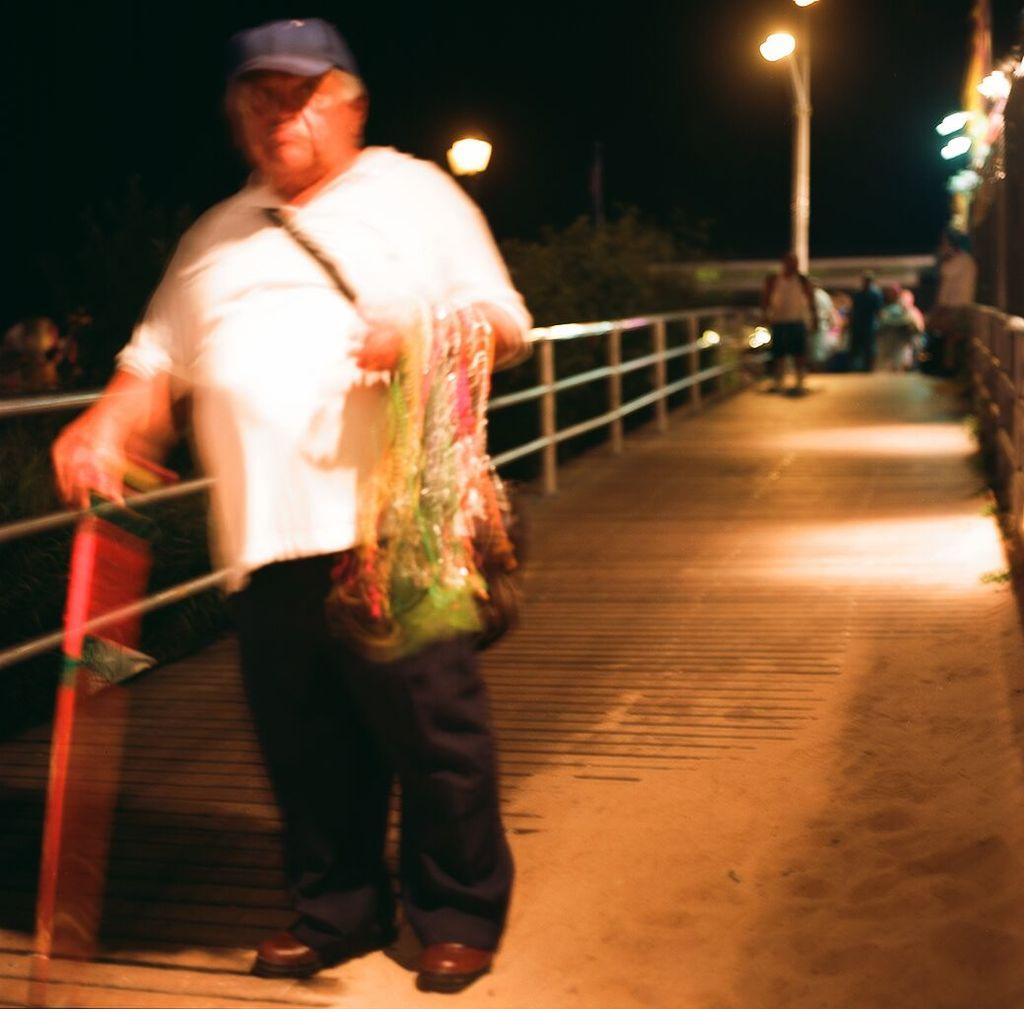What is the position of the man in the image? The man is on the left side of the image. Are there any other people in the image besides the man? Yes, there are other people on the right side of the image. What can be seen at the top side of the image? There is a pole at the top side of the image. How many books can be seen in the man's eye in the image? There are no books visible in the man's eye in the image. 